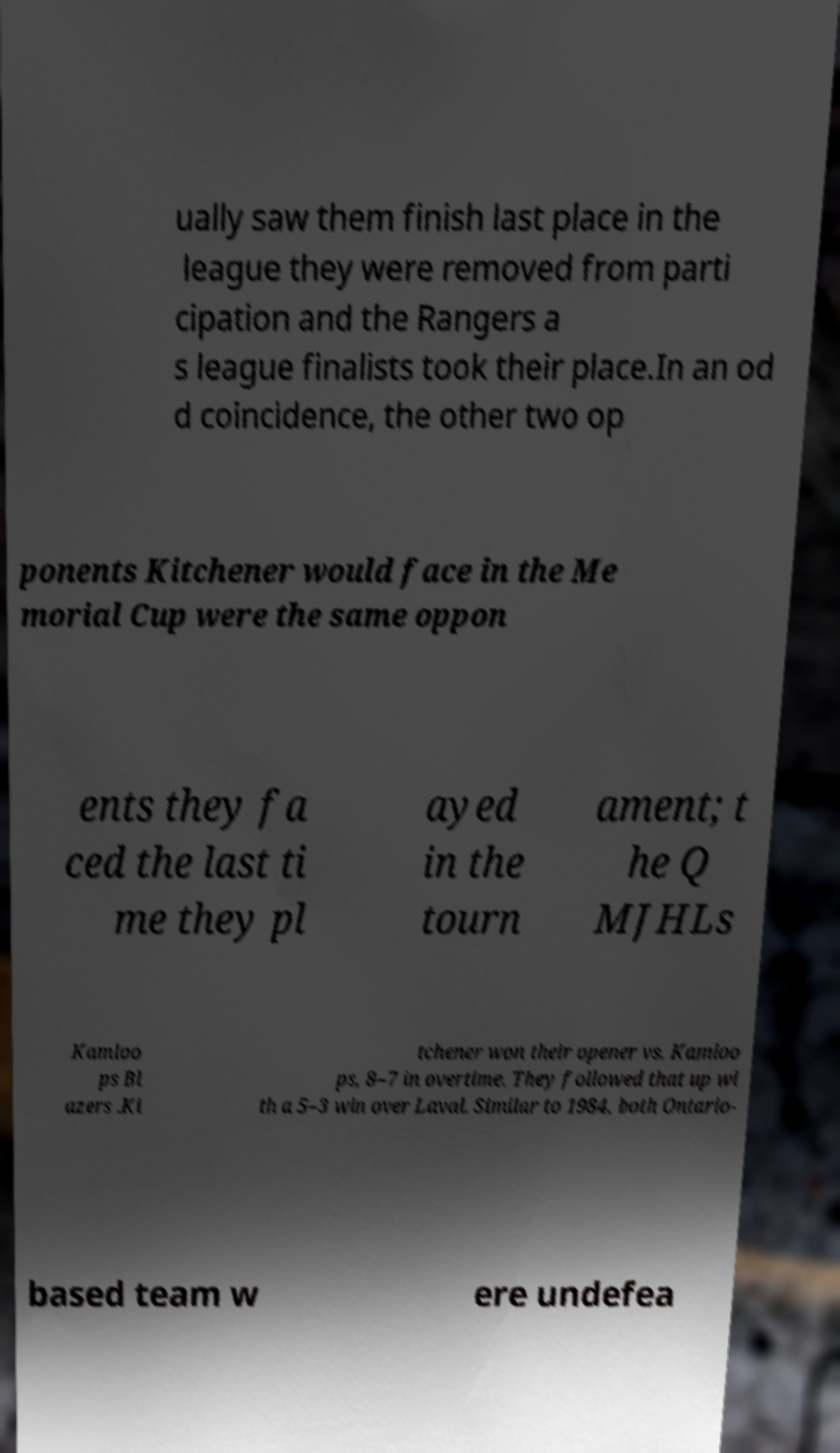Please identify and transcribe the text found in this image. ually saw them finish last place in the league they were removed from parti cipation and the Rangers a s league finalists took their place.In an od d coincidence, the other two op ponents Kitchener would face in the Me morial Cup were the same oppon ents they fa ced the last ti me they pl ayed in the tourn ament; t he Q MJHLs Kamloo ps Bl azers .Ki tchener won their opener vs. Kamloo ps, 8–7 in overtime. They followed that up wi th a 5–3 win over Laval. Similar to 1984, both Ontario- based team w ere undefea 